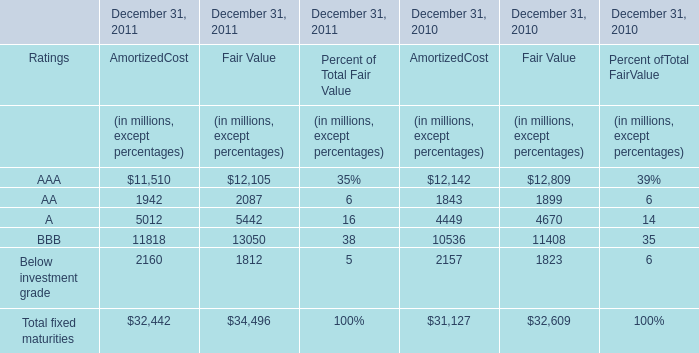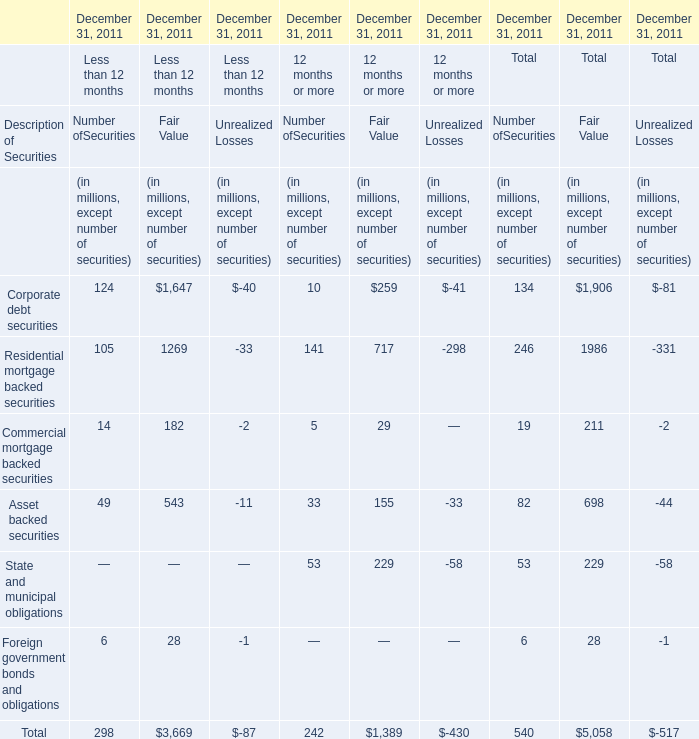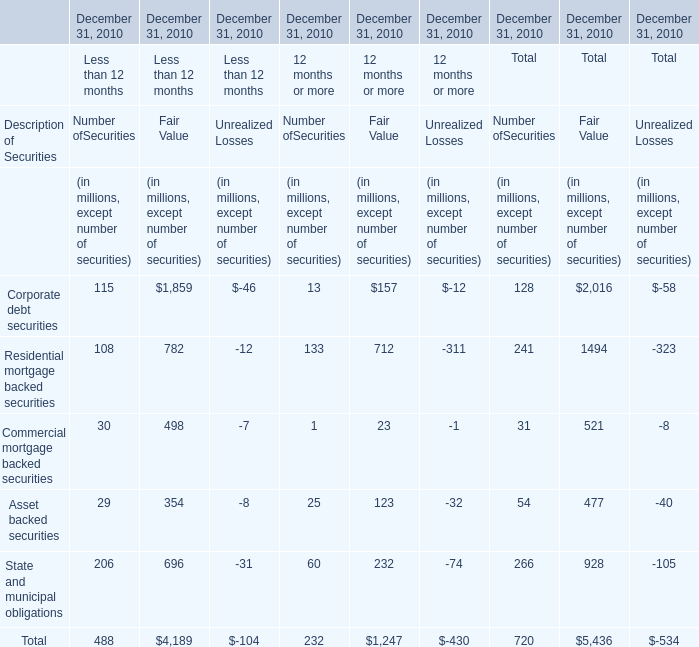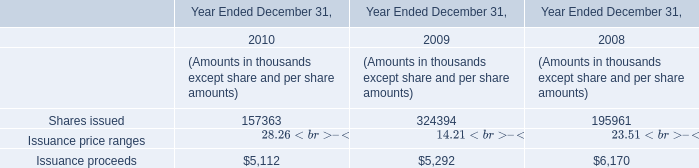In the year with less amount of Issuance proceeds, what's the sum of Commercial mortgage backed securities in 2010? 
Computations: ((((((((30 + 498) - 7) + 1) + 23) - 1) + 31) + 521) - 8)
Answer: 1088.0. 